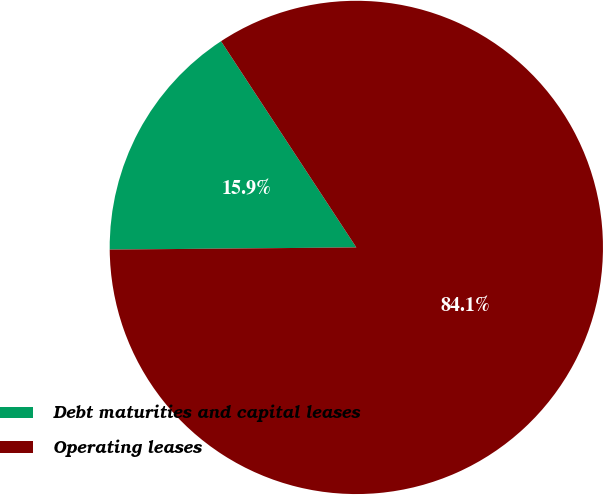<chart> <loc_0><loc_0><loc_500><loc_500><pie_chart><fcel>Debt maturities and capital leases<fcel>Operating leases<nl><fcel>15.9%<fcel>84.1%<nl></chart> 